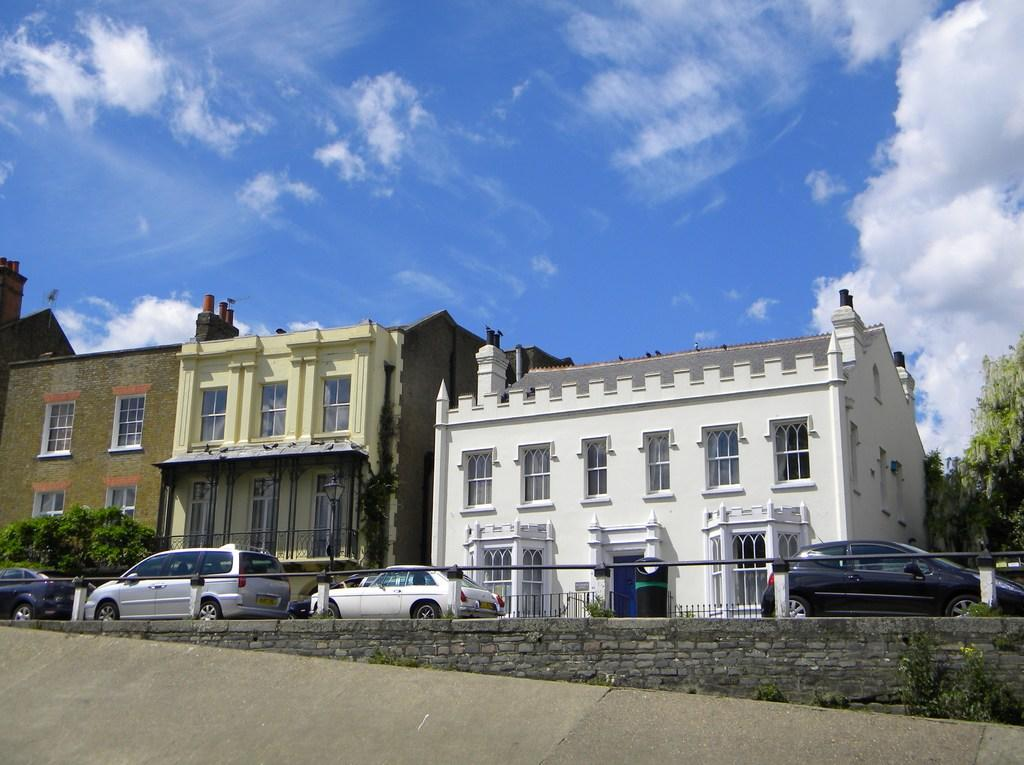What is one of the main features in the image? There is a wall in the image. What else can be seen in the image? There are plants, a rod, cars, and a bin in the image. What can be seen in the background of the image? In the background, there are buildings, trees, and the sky. What is the condition of the sky in the image? Clouds are present in the sky. What type of lamp is hanging from the wall in the image? There is no lamp present in the image. What company is associated with the cars in the image? The image does not provide information about the car manufacturers or any associated companies. 